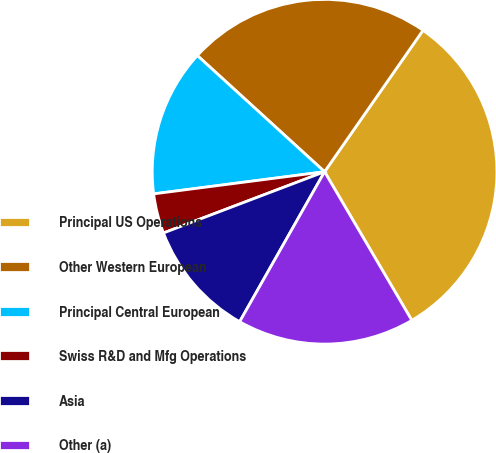Convert chart to OTSL. <chart><loc_0><loc_0><loc_500><loc_500><pie_chart><fcel>Principal US Operations<fcel>Other Western European<fcel>Principal Central European<fcel>Swiss R&D and Mfg Operations<fcel>Asia<fcel>Other (a)<nl><fcel>31.87%<fcel>22.9%<fcel>13.83%<fcel>3.73%<fcel>11.02%<fcel>16.65%<nl></chart> 